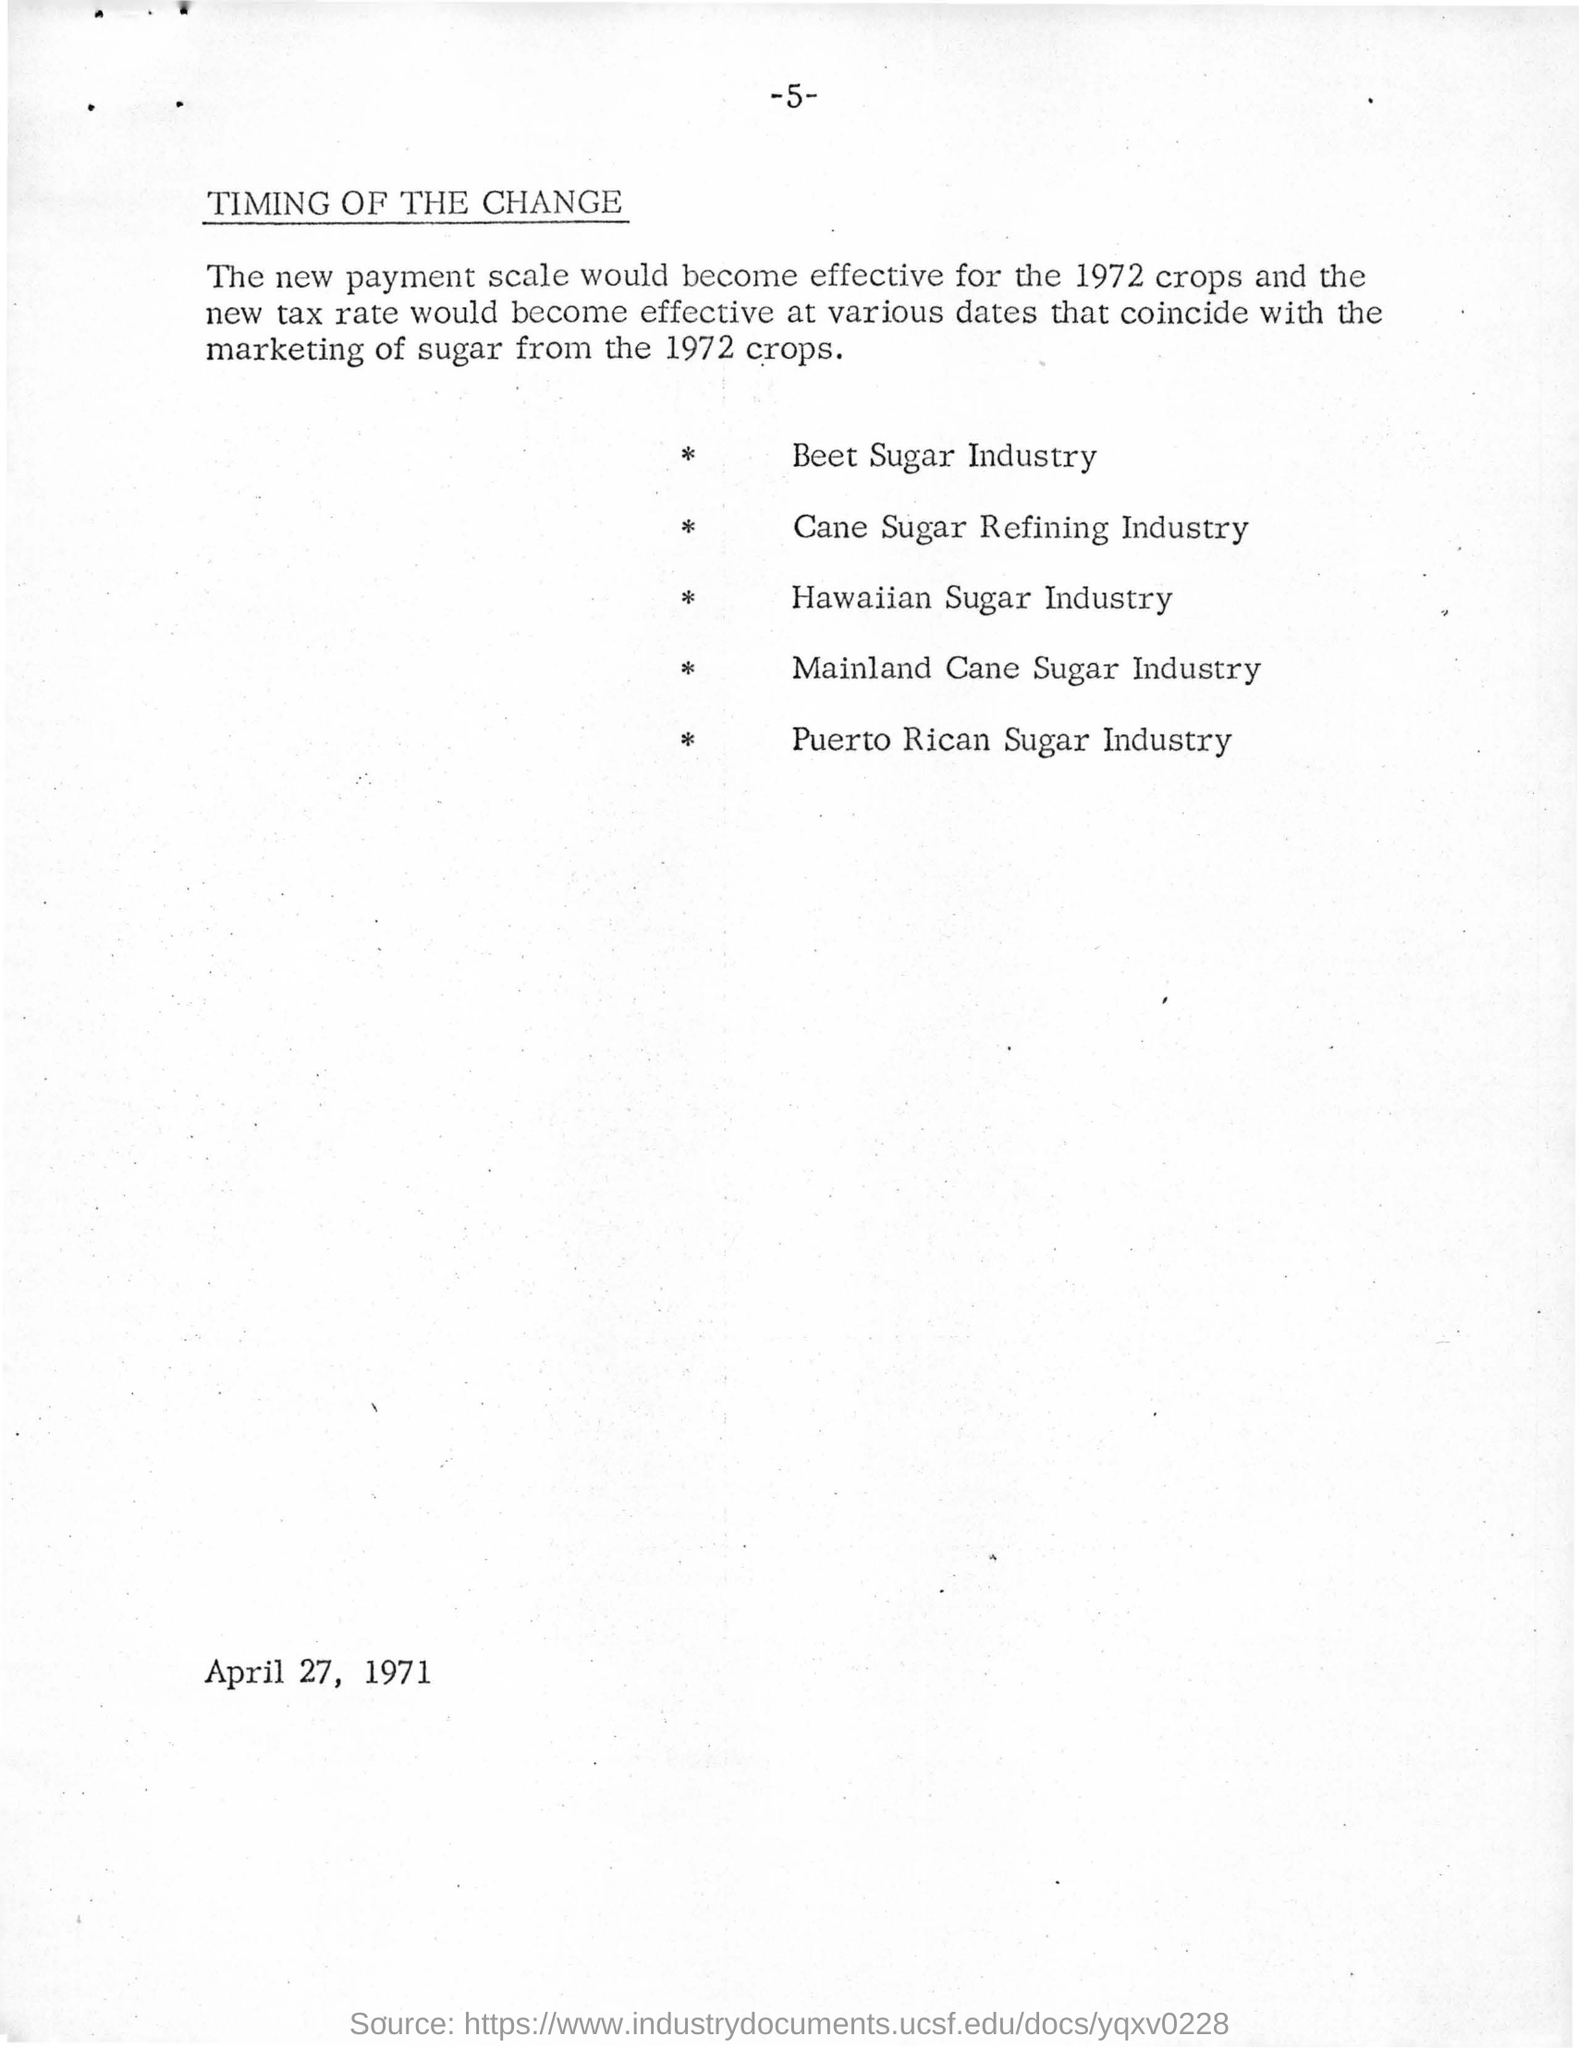Draw attention to some important aspects in this diagram. The page number mentioned in this document is 5. The date mentioned in the document is April 27, 1971. 